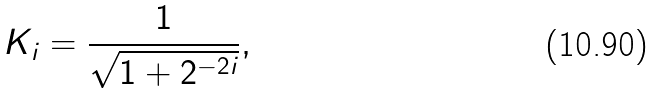<formula> <loc_0><loc_0><loc_500><loc_500>K _ { i } = { \frac { 1 } { \sqrt { 1 + 2 ^ { - 2 i } } } } ,</formula> 